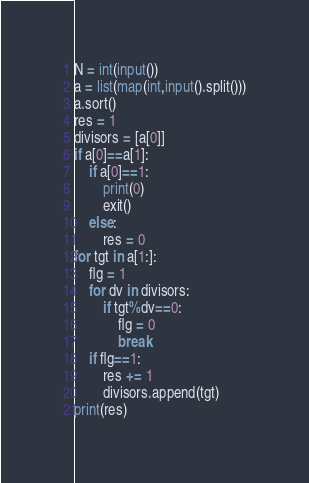Convert code to text. <code><loc_0><loc_0><loc_500><loc_500><_Python_>N = int(input())
a = list(map(int,input().split()))
a.sort()
res = 1
divisors = [a[0]]
if a[0]==a[1]:
    if a[0]==1:
        print(0)
        exit()
    else:
        res = 0
for tgt in a[1:]:
    flg = 1
    for dv in divisors:
        if tgt%dv==0:
            flg = 0
            break
    if flg==1:
        res += 1
        divisors.append(tgt)
print(res)

</code> 